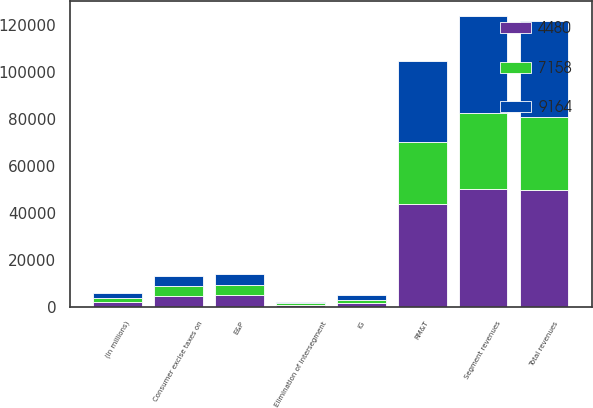Convert chart to OTSL. <chart><loc_0><loc_0><loc_500><loc_500><stacked_bar_chart><ecel><fcel>(In millions)<fcel>E&P<fcel>RM&T<fcel>IG<fcel>Segment revenues<fcel>Elimination of intersegment<fcel>Total revenues<fcel>Consumer excise taxes on<nl><fcel>4480<fcel>2004<fcel>4897<fcel>43630<fcel>1739<fcel>50266<fcel>668<fcel>49598<fcel>4463<nl><fcel>9164<fcel>2003<fcel>4811<fcel>34514<fcel>2248<fcel>41573<fcel>610<fcel>40963<fcel>4285<nl><fcel>7158<fcel>2002<fcel>4477<fcel>26399<fcel>1217<fcel>32093<fcel>798<fcel>31295<fcel>4250<nl></chart> 